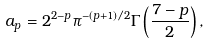<formula> <loc_0><loc_0><loc_500><loc_500>a _ { p } = 2 ^ { 2 - p } \pi ^ { - ( p + 1 ) / 2 } \Gamma \left ( \frac { 7 - p } { 2 } \right ) ,</formula> 